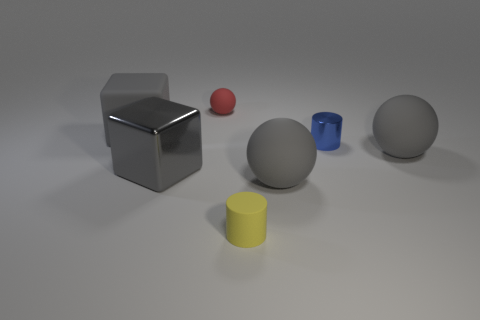Subtract all tiny balls. How many balls are left? 2 Subtract 2 blocks. How many blocks are left? 0 Subtract all gray cubes. How many gray spheres are left? 2 Subtract all red balls. How many balls are left? 2 Add 1 shiny blocks. How many objects exist? 8 Add 4 big rubber cubes. How many big rubber cubes exist? 5 Subtract 0 blue blocks. How many objects are left? 7 Subtract all balls. How many objects are left? 4 Subtract all purple balls. Subtract all gray blocks. How many balls are left? 3 Subtract all small blue objects. Subtract all gray matte balls. How many objects are left? 4 